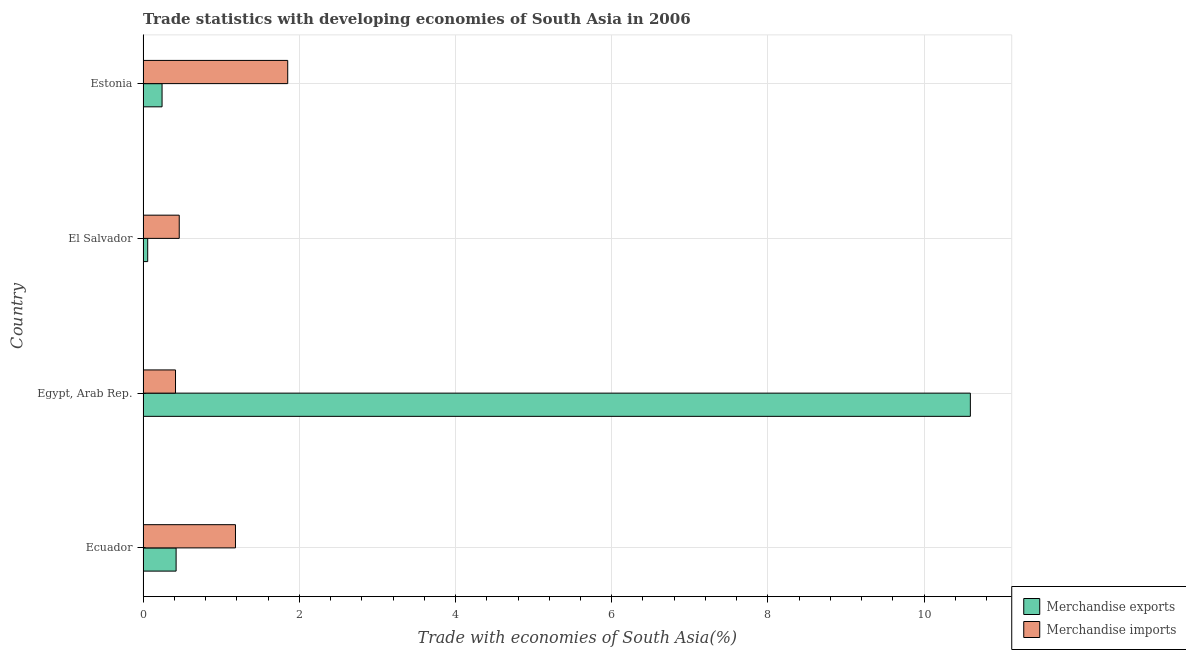How many groups of bars are there?
Ensure brevity in your answer.  4. Are the number of bars per tick equal to the number of legend labels?
Ensure brevity in your answer.  Yes. How many bars are there on the 4th tick from the top?
Offer a very short reply. 2. What is the label of the 4th group of bars from the top?
Keep it short and to the point. Ecuador. In how many cases, is the number of bars for a given country not equal to the number of legend labels?
Your response must be concise. 0. What is the merchandise exports in Egypt, Arab Rep.?
Make the answer very short. 10.59. Across all countries, what is the maximum merchandise exports?
Give a very brief answer. 10.59. Across all countries, what is the minimum merchandise exports?
Offer a terse response. 0.06. In which country was the merchandise exports maximum?
Keep it short and to the point. Egypt, Arab Rep. In which country was the merchandise imports minimum?
Make the answer very short. Egypt, Arab Rep. What is the total merchandise exports in the graph?
Ensure brevity in your answer.  11.32. What is the difference between the merchandise imports in El Salvador and that in Estonia?
Your answer should be compact. -1.39. What is the difference between the merchandise exports in Estonia and the merchandise imports in Egypt, Arab Rep.?
Provide a short and direct response. -0.17. What is the average merchandise exports per country?
Provide a short and direct response. 2.83. What is the difference between the merchandise exports and merchandise imports in El Salvador?
Make the answer very short. -0.4. What is the ratio of the merchandise exports in Ecuador to that in Estonia?
Make the answer very short. 1.74. Is the difference between the merchandise imports in Ecuador and Estonia greater than the difference between the merchandise exports in Ecuador and Estonia?
Offer a terse response. No. What is the difference between the highest and the second highest merchandise exports?
Keep it short and to the point. 10.17. What is the difference between the highest and the lowest merchandise imports?
Your answer should be very brief. 1.44. How many countries are there in the graph?
Offer a terse response. 4. What is the difference between two consecutive major ticks on the X-axis?
Provide a short and direct response. 2. Does the graph contain any zero values?
Make the answer very short. No. Where does the legend appear in the graph?
Your response must be concise. Bottom right. How many legend labels are there?
Your response must be concise. 2. How are the legend labels stacked?
Keep it short and to the point. Vertical. What is the title of the graph?
Provide a short and direct response. Trade statistics with developing economies of South Asia in 2006. Does "Registered firms" appear as one of the legend labels in the graph?
Ensure brevity in your answer.  No. What is the label or title of the X-axis?
Provide a succinct answer. Trade with economies of South Asia(%). What is the label or title of the Y-axis?
Offer a very short reply. Country. What is the Trade with economies of South Asia(%) of Merchandise exports in Ecuador?
Offer a very short reply. 0.42. What is the Trade with economies of South Asia(%) in Merchandise imports in Ecuador?
Ensure brevity in your answer.  1.18. What is the Trade with economies of South Asia(%) of Merchandise exports in Egypt, Arab Rep.?
Offer a very short reply. 10.59. What is the Trade with economies of South Asia(%) of Merchandise imports in Egypt, Arab Rep.?
Your answer should be very brief. 0.42. What is the Trade with economies of South Asia(%) in Merchandise exports in El Salvador?
Offer a very short reply. 0.06. What is the Trade with economies of South Asia(%) of Merchandise imports in El Salvador?
Provide a short and direct response. 0.46. What is the Trade with economies of South Asia(%) of Merchandise exports in Estonia?
Your answer should be compact. 0.24. What is the Trade with economies of South Asia(%) of Merchandise imports in Estonia?
Offer a terse response. 1.85. Across all countries, what is the maximum Trade with economies of South Asia(%) in Merchandise exports?
Offer a terse response. 10.59. Across all countries, what is the maximum Trade with economies of South Asia(%) of Merchandise imports?
Offer a very short reply. 1.85. Across all countries, what is the minimum Trade with economies of South Asia(%) of Merchandise exports?
Make the answer very short. 0.06. Across all countries, what is the minimum Trade with economies of South Asia(%) of Merchandise imports?
Your response must be concise. 0.42. What is the total Trade with economies of South Asia(%) in Merchandise exports in the graph?
Your answer should be compact. 11.32. What is the total Trade with economies of South Asia(%) in Merchandise imports in the graph?
Provide a short and direct response. 3.91. What is the difference between the Trade with economies of South Asia(%) of Merchandise exports in Ecuador and that in Egypt, Arab Rep.?
Offer a very short reply. -10.17. What is the difference between the Trade with economies of South Asia(%) of Merchandise imports in Ecuador and that in Egypt, Arab Rep.?
Ensure brevity in your answer.  0.77. What is the difference between the Trade with economies of South Asia(%) in Merchandise exports in Ecuador and that in El Salvador?
Ensure brevity in your answer.  0.36. What is the difference between the Trade with economies of South Asia(%) in Merchandise imports in Ecuador and that in El Salvador?
Ensure brevity in your answer.  0.72. What is the difference between the Trade with economies of South Asia(%) in Merchandise exports in Ecuador and that in Estonia?
Your answer should be compact. 0.18. What is the difference between the Trade with economies of South Asia(%) in Merchandise imports in Ecuador and that in Estonia?
Ensure brevity in your answer.  -0.67. What is the difference between the Trade with economies of South Asia(%) in Merchandise exports in Egypt, Arab Rep. and that in El Salvador?
Make the answer very short. 10.53. What is the difference between the Trade with economies of South Asia(%) in Merchandise imports in Egypt, Arab Rep. and that in El Salvador?
Your answer should be compact. -0.05. What is the difference between the Trade with economies of South Asia(%) in Merchandise exports in Egypt, Arab Rep. and that in Estonia?
Your answer should be compact. 10.35. What is the difference between the Trade with economies of South Asia(%) in Merchandise imports in Egypt, Arab Rep. and that in Estonia?
Give a very brief answer. -1.44. What is the difference between the Trade with economies of South Asia(%) in Merchandise exports in El Salvador and that in Estonia?
Offer a terse response. -0.18. What is the difference between the Trade with economies of South Asia(%) of Merchandise imports in El Salvador and that in Estonia?
Give a very brief answer. -1.39. What is the difference between the Trade with economies of South Asia(%) of Merchandise exports in Ecuador and the Trade with economies of South Asia(%) of Merchandise imports in Egypt, Arab Rep.?
Your response must be concise. 0.01. What is the difference between the Trade with economies of South Asia(%) of Merchandise exports in Ecuador and the Trade with economies of South Asia(%) of Merchandise imports in El Salvador?
Give a very brief answer. -0.04. What is the difference between the Trade with economies of South Asia(%) of Merchandise exports in Ecuador and the Trade with economies of South Asia(%) of Merchandise imports in Estonia?
Your response must be concise. -1.43. What is the difference between the Trade with economies of South Asia(%) in Merchandise exports in Egypt, Arab Rep. and the Trade with economies of South Asia(%) in Merchandise imports in El Salvador?
Your answer should be compact. 10.13. What is the difference between the Trade with economies of South Asia(%) of Merchandise exports in Egypt, Arab Rep. and the Trade with economies of South Asia(%) of Merchandise imports in Estonia?
Offer a terse response. 8.74. What is the difference between the Trade with economies of South Asia(%) in Merchandise exports in El Salvador and the Trade with economies of South Asia(%) in Merchandise imports in Estonia?
Provide a short and direct response. -1.79. What is the average Trade with economies of South Asia(%) in Merchandise exports per country?
Your answer should be very brief. 2.83. What is the average Trade with economies of South Asia(%) of Merchandise imports per country?
Provide a short and direct response. 0.98. What is the difference between the Trade with economies of South Asia(%) of Merchandise exports and Trade with economies of South Asia(%) of Merchandise imports in Ecuador?
Your answer should be very brief. -0.76. What is the difference between the Trade with economies of South Asia(%) in Merchandise exports and Trade with economies of South Asia(%) in Merchandise imports in Egypt, Arab Rep.?
Offer a terse response. 10.18. What is the difference between the Trade with economies of South Asia(%) of Merchandise exports and Trade with economies of South Asia(%) of Merchandise imports in El Salvador?
Your response must be concise. -0.4. What is the difference between the Trade with economies of South Asia(%) in Merchandise exports and Trade with economies of South Asia(%) in Merchandise imports in Estonia?
Make the answer very short. -1.61. What is the ratio of the Trade with economies of South Asia(%) of Merchandise exports in Ecuador to that in Egypt, Arab Rep.?
Your answer should be compact. 0.04. What is the ratio of the Trade with economies of South Asia(%) of Merchandise imports in Ecuador to that in Egypt, Arab Rep.?
Your answer should be compact. 2.85. What is the ratio of the Trade with economies of South Asia(%) of Merchandise exports in Ecuador to that in El Salvador?
Make the answer very short. 7.12. What is the ratio of the Trade with economies of South Asia(%) in Merchandise imports in Ecuador to that in El Salvador?
Provide a succinct answer. 2.55. What is the ratio of the Trade with economies of South Asia(%) in Merchandise exports in Ecuador to that in Estonia?
Offer a very short reply. 1.74. What is the ratio of the Trade with economies of South Asia(%) of Merchandise imports in Ecuador to that in Estonia?
Make the answer very short. 0.64. What is the ratio of the Trade with economies of South Asia(%) in Merchandise exports in Egypt, Arab Rep. to that in El Salvador?
Provide a succinct answer. 178.25. What is the ratio of the Trade with economies of South Asia(%) in Merchandise imports in Egypt, Arab Rep. to that in El Salvador?
Offer a terse response. 0.9. What is the ratio of the Trade with economies of South Asia(%) of Merchandise exports in Egypt, Arab Rep. to that in Estonia?
Your answer should be compact. 43.55. What is the ratio of the Trade with economies of South Asia(%) of Merchandise imports in Egypt, Arab Rep. to that in Estonia?
Make the answer very short. 0.22. What is the ratio of the Trade with economies of South Asia(%) of Merchandise exports in El Salvador to that in Estonia?
Your answer should be very brief. 0.24. What is the ratio of the Trade with economies of South Asia(%) in Merchandise imports in El Salvador to that in Estonia?
Give a very brief answer. 0.25. What is the difference between the highest and the second highest Trade with economies of South Asia(%) in Merchandise exports?
Give a very brief answer. 10.17. What is the difference between the highest and the second highest Trade with economies of South Asia(%) in Merchandise imports?
Provide a short and direct response. 0.67. What is the difference between the highest and the lowest Trade with economies of South Asia(%) of Merchandise exports?
Offer a terse response. 10.53. What is the difference between the highest and the lowest Trade with economies of South Asia(%) in Merchandise imports?
Offer a terse response. 1.44. 